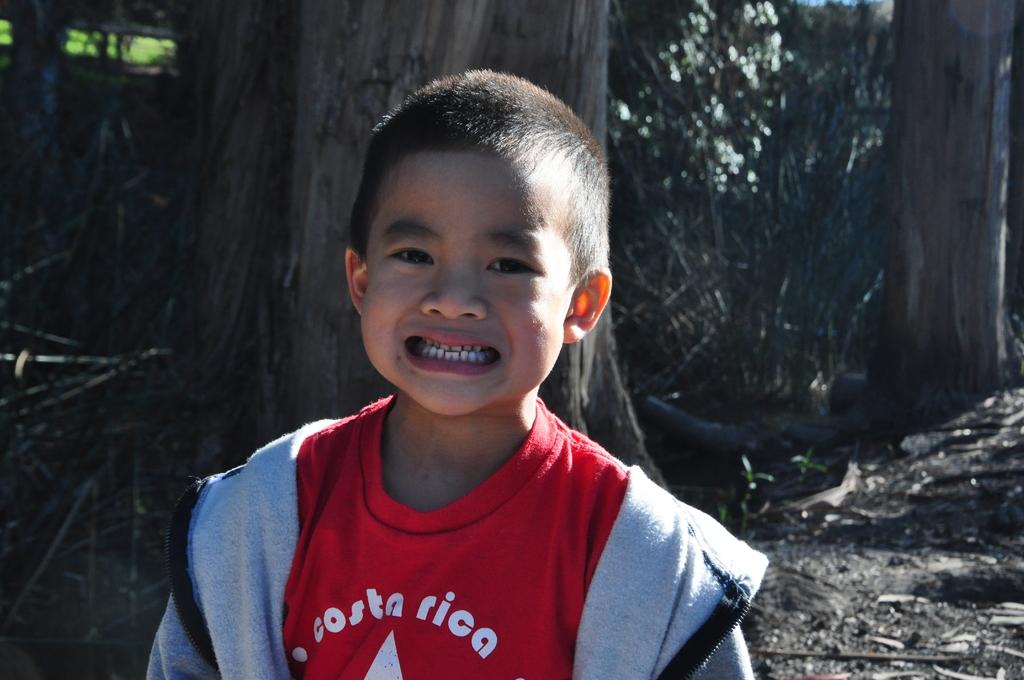Who is present in the image? There is a boy in the picture. What is the boy doing in the image? The boy is smiling and showing his teeth. What can be seen in the background of the picture? There are trees in the background of the picture. What type of grain is visible in the image? There is no grain present in the image. Is there a van parked near the trees in the background? There is no van mentioned or visible in the image. 